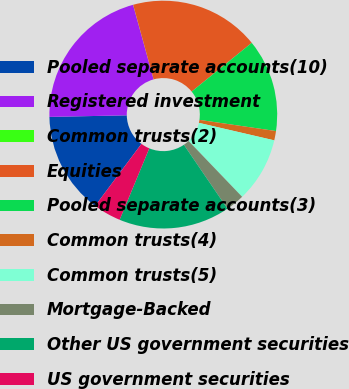Convert chart to OTSL. <chart><loc_0><loc_0><loc_500><loc_500><pie_chart><fcel>Pooled separate accounts(10)<fcel>Registered investment<fcel>Common trusts(2)<fcel>Equities<fcel>Pooled separate accounts(3)<fcel>Common trusts(4)<fcel>Common trusts(5)<fcel>Mortgage-Backed<fcel>Other US government securities<fcel>US government securities<nl><fcel>14.47%<fcel>21.05%<fcel>0.01%<fcel>18.42%<fcel>13.16%<fcel>1.32%<fcel>9.21%<fcel>2.64%<fcel>15.79%<fcel>3.95%<nl></chart> 